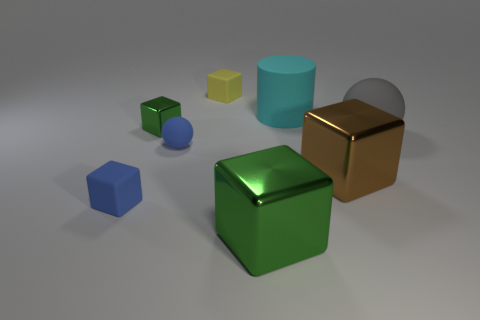Add 1 gray metallic objects. How many objects exist? 9 Subtract 1 spheres. How many spheres are left? 1 Subtract all gray cylinders. Subtract all blue cubes. How many cylinders are left? 1 Subtract all cyan cylinders. How many brown cubes are left? 1 Subtract all green spheres. Subtract all green objects. How many objects are left? 6 Add 4 small blue rubber objects. How many small blue rubber objects are left? 6 Add 8 blue matte things. How many blue matte things exist? 10 Subtract all green blocks. How many blocks are left? 3 Subtract all large brown cubes. How many cubes are left? 4 Subtract 0 purple spheres. How many objects are left? 8 